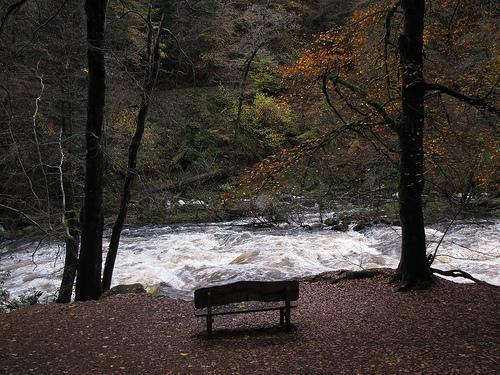How many benches are there?
Give a very brief answer. 1. 